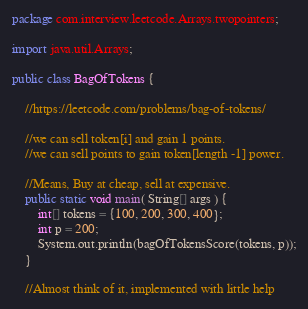Convert code to text. <code><loc_0><loc_0><loc_500><loc_500><_Java_>package com.interview.leetcode.Arrays.twopointers;

import java.util.Arrays;

public class BagOfTokens {

    //https://leetcode.com/problems/bag-of-tokens/

    //we can sell token[i] and gain 1 points.
    //we can sell points to gain token[length -1] power.

    //Means, Buy at cheap, sell at expensive.
    public static void main( String[] args ) {
        int[] tokens = {100, 200, 300, 400};
        int p = 200;
        System.out.println(bagOfTokensScore(tokens, p));
    }

    //Almost think of it, implemented with little help</code> 